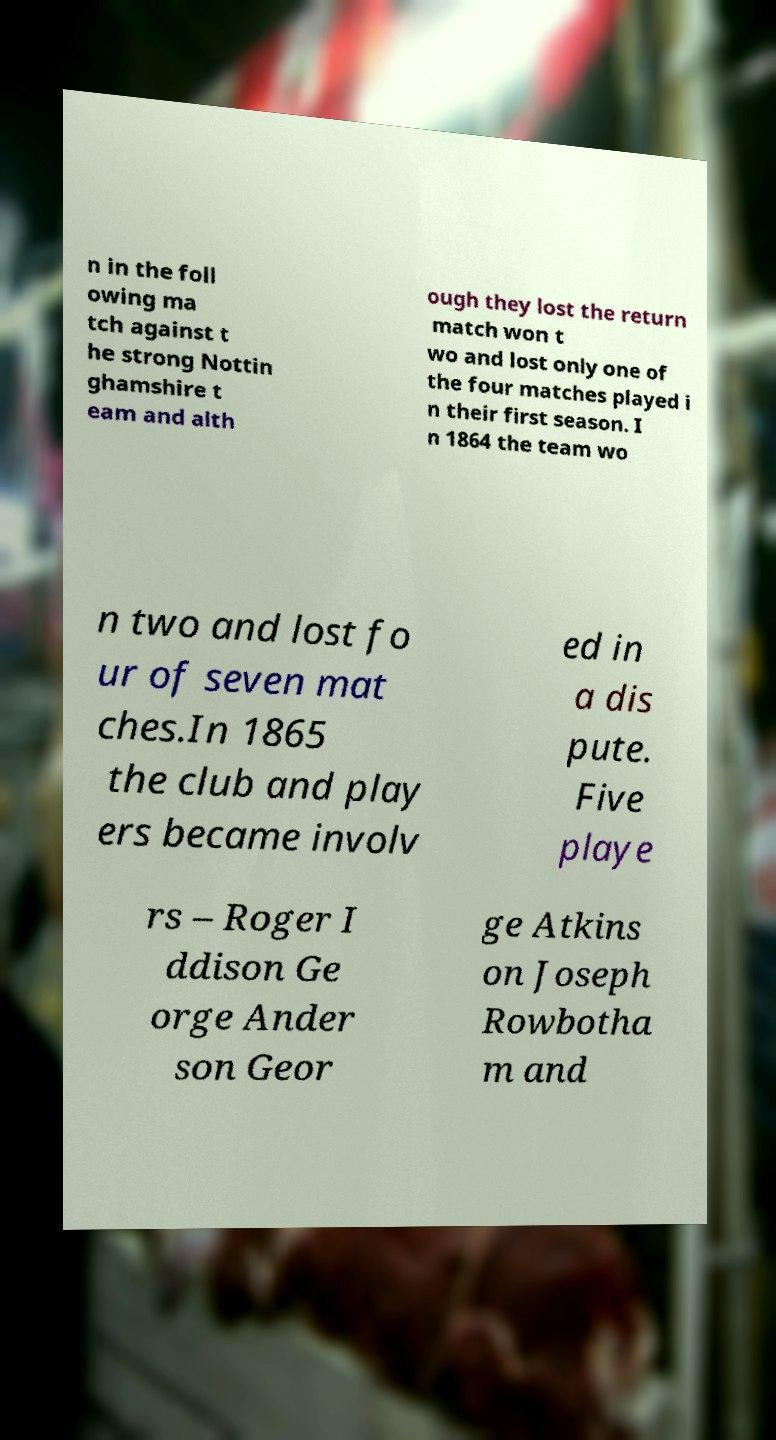Could you assist in decoding the text presented in this image and type it out clearly? n in the foll owing ma tch against t he strong Nottin ghamshire t eam and alth ough they lost the return match won t wo and lost only one of the four matches played i n their first season. I n 1864 the team wo n two and lost fo ur of seven mat ches.In 1865 the club and play ers became involv ed in a dis pute. Five playe rs – Roger I ddison Ge orge Ander son Geor ge Atkins on Joseph Rowbotha m and 